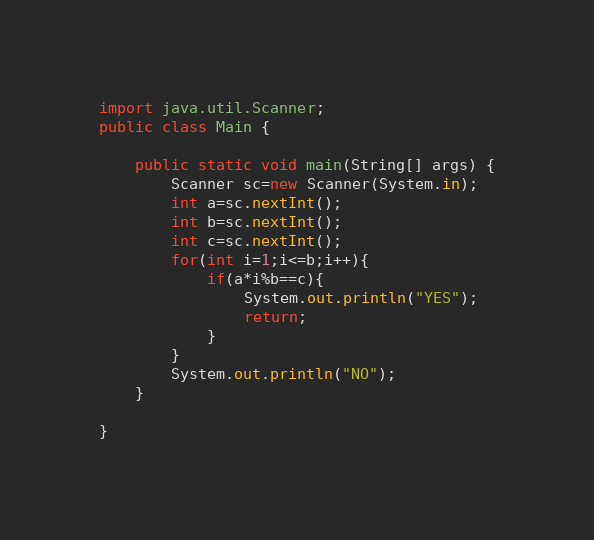Convert code to text. <code><loc_0><loc_0><loc_500><loc_500><_Java_>import java.util.Scanner;
public class Main {

	public static void main(String[] args) {
		Scanner sc=new Scanner(System.in);
		int a=sc.nextInt();
		int b=sc.nextInt();
		int c=sc.nextInt();
		for(int i=1;i<=b;i++){
			if(a*i%b==c){
				System.out.println("YES");
				return;
			}
		}
		System.out.println("NO");
	}

}
</code> 